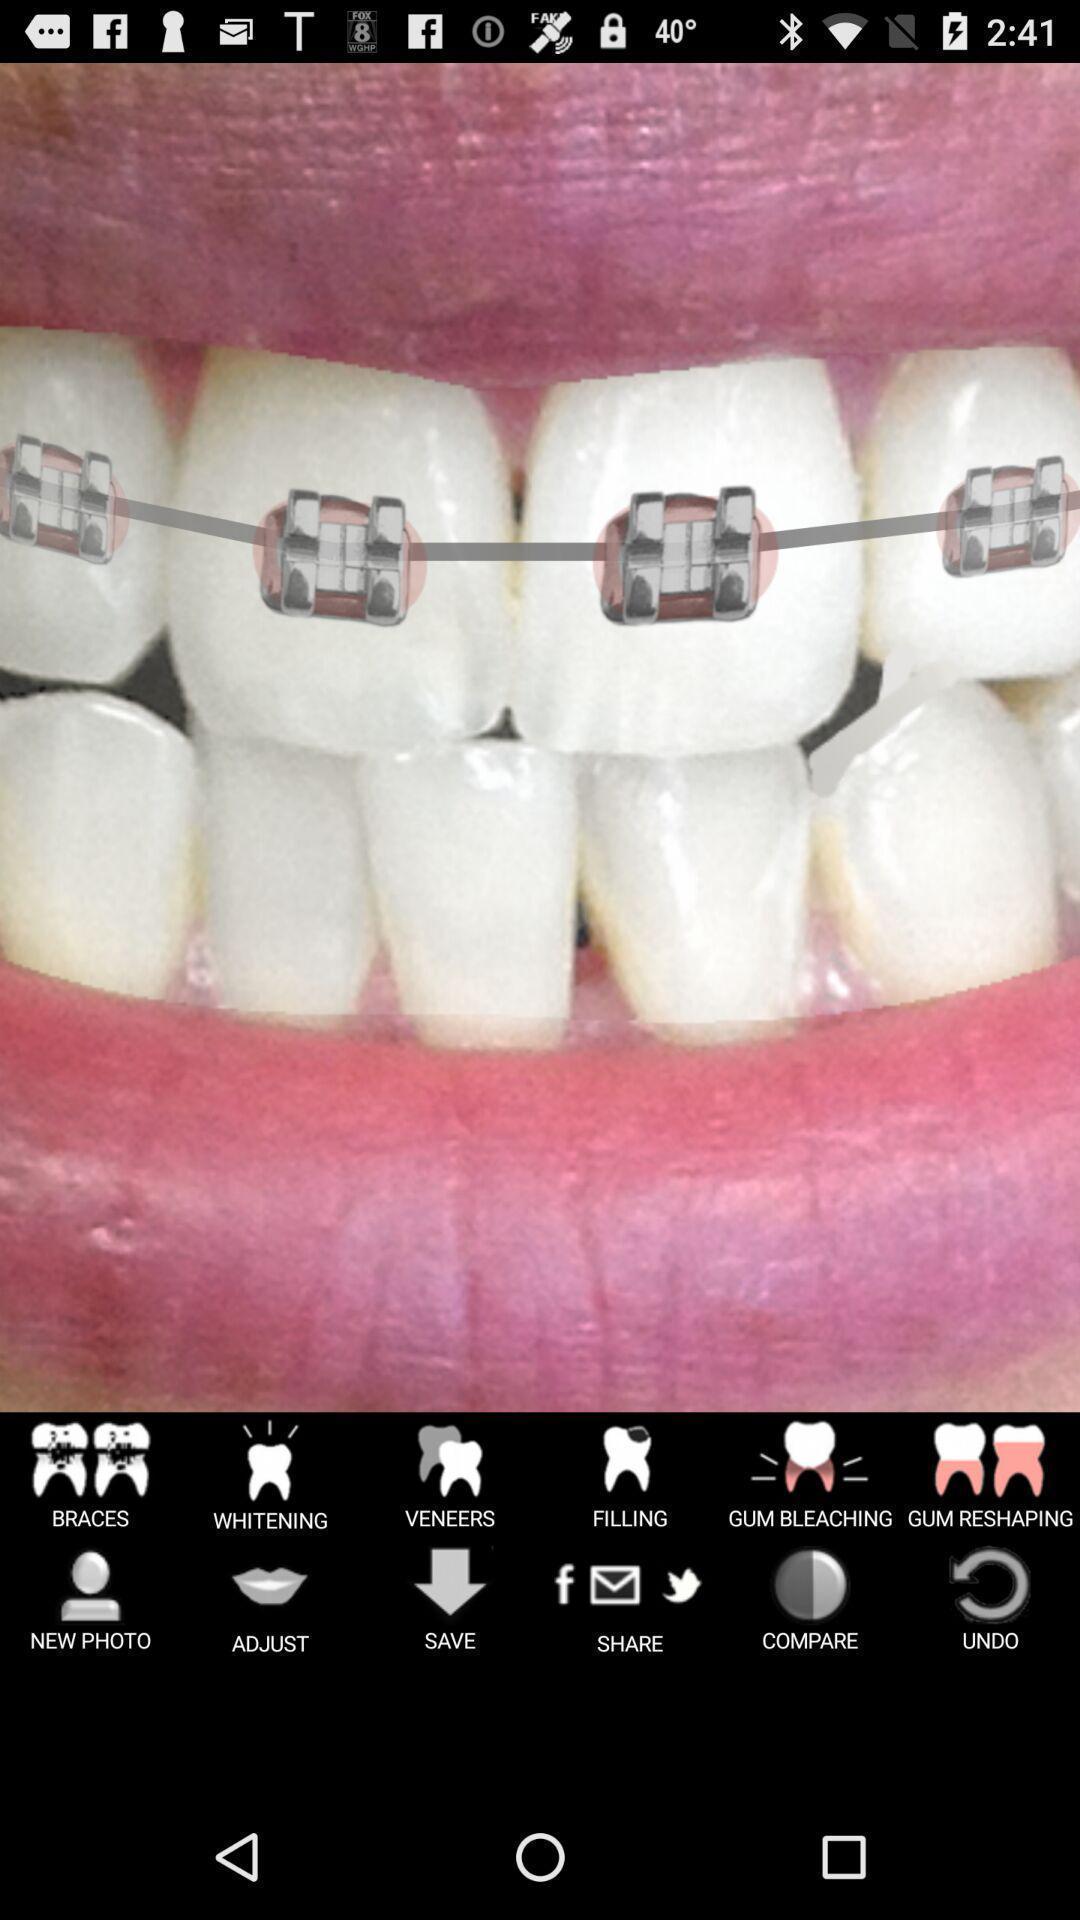What is the overall content of this screenshot? Screen showing page of an dental application with options. 